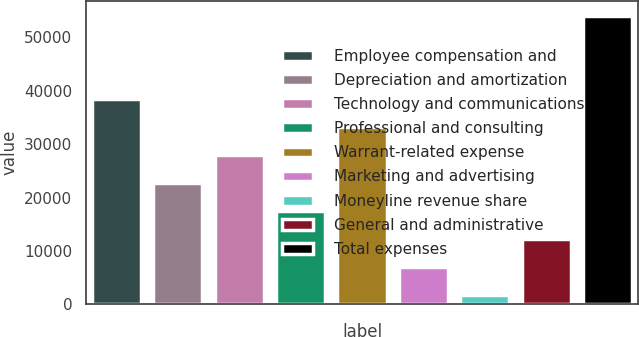Convert chart. <chart><loc_0><loc_0><loc_500><loc_500><bar_chart><fcel>Employee compensation and<fcel>Depreciation and amortization<fcel>Technology and communications<fcel>Professional and consulting<fcel>Warrant-related expense<fcel>Marketing and advertising<fcel>Moneyline revenue share<fcel>General and administrative<fcel>Total expenses<nl><fcel>38382.4<fcel>22706.8<fcel>27932<fcel>17481.6<fcel>33157.2<fcel>7031.2<fcel>1806<fcel>12256.4<fcel>54058<nl></chart> 